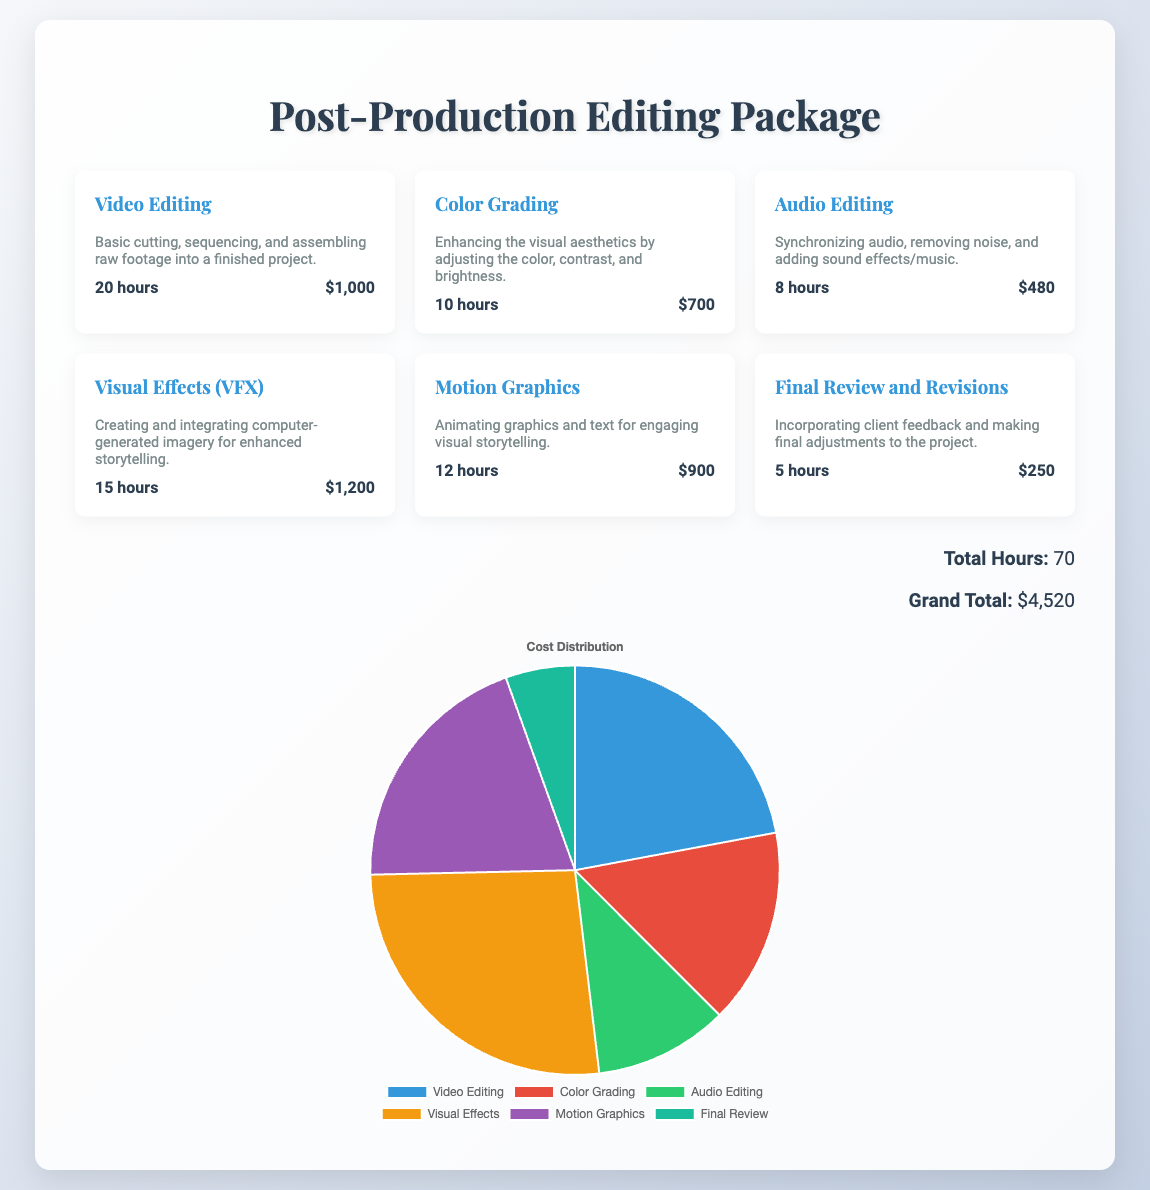what is the total number of hours worked? The total number of hours worked is highlighted in the total section as the sum of hours for each service.
Answer: 70 what is the cost of Visual Effects (VFX)? The cost of Visual Effects (VFX) is specifically mentioned in the details of the service.
Answer: $1,200 how many hours were spent on Audio Editing? The hours for Audio Editing are specified in the service details.
Answer: 8 hours what is the grand total cost for the post-production package? The grand total is summarized at the end of the document in the total section.
Answer: $4,520 which service involves animating graphics and text? The service that involves animating graphics and text is explicitly mentioned in the title of that service.
Answer: Motion Graphics what percentage of the total cost is allocated to Color Grading? The percentage of the total cost allocated to Color Grading can be derived from the costs of all services outlined in the pie chart.
Answer: 15.5% how many hours are dedicated to Final Review and Revisions? The hours dedicated to Final Review and Revisions are specified in the service details.
Answer: 5 hours what is the description of the Video Editing service? The description for the Video Editing service provides insight into what tasks are included and is directly mentioned below the title.
Answer: Basic cutting, sequencing, and assembling raw footage into a finished project which service has the highest cost? The highest cost among the listed services can be determined by comparing the costs provided for each service.
Answer: Visual Effects (VFX) 